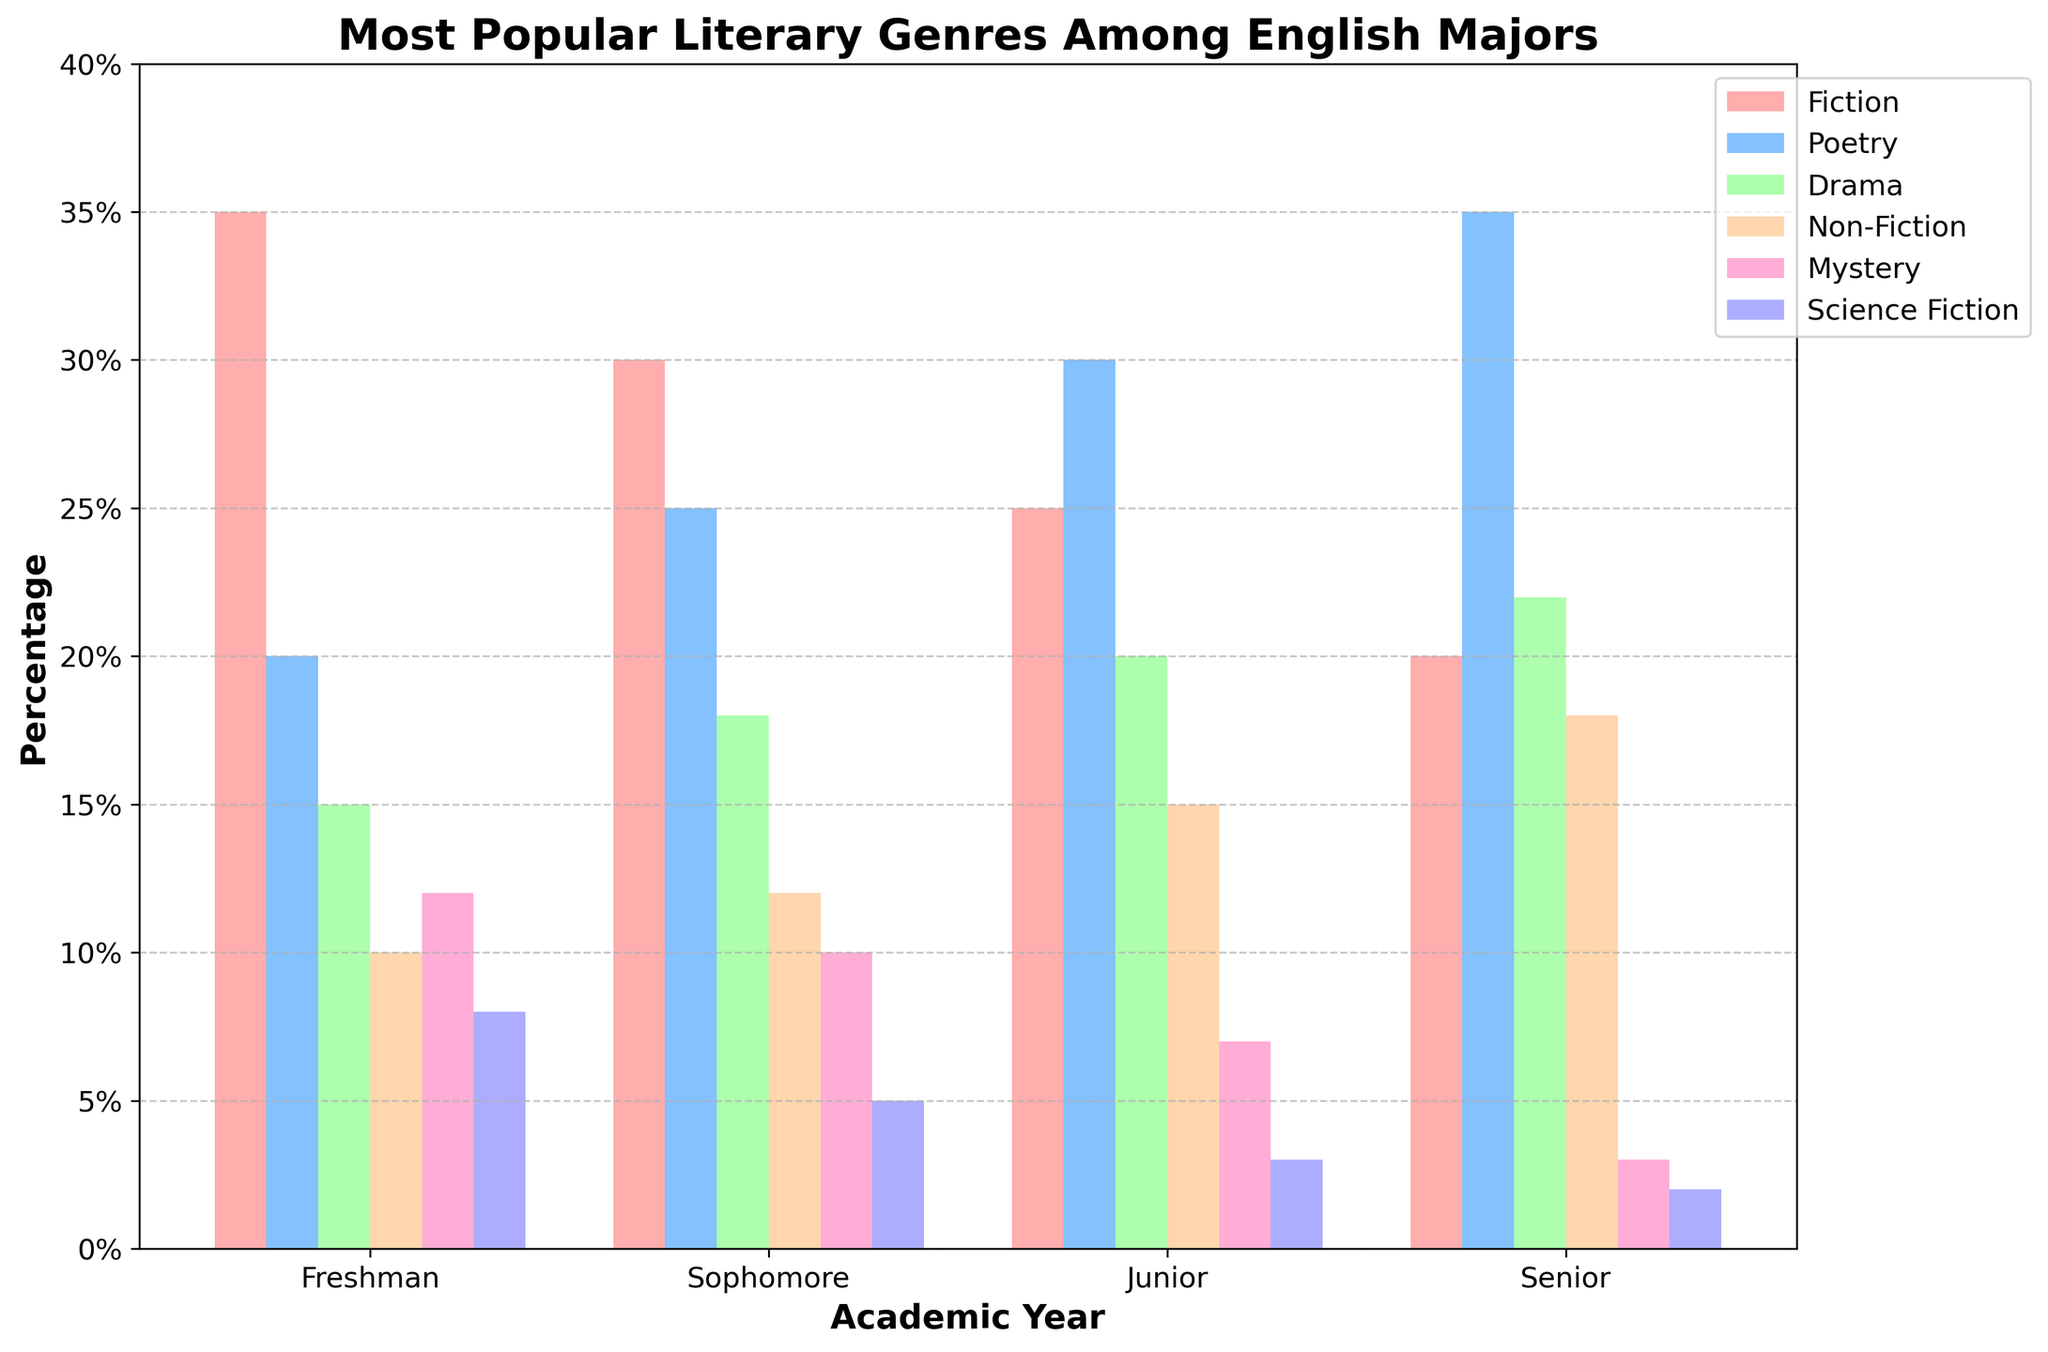How many more students prefer Fiction than Science Fiction in the Freshman year? To find the difference, subtract the number of students who prefer Science Fiction from those who prefer Fiction in the Freshman year: 35 - 8 = 27
Answer: 27 In which academic year is Poetry the most preferred genre? Review the height of the bars representing Poetry across the years; the highest is in the Senior year with 35 students.
Answer: Senior Which genre sees the most consistent increase in preference from Freshman to Senior years? Compare the change in height of each genre’s bar from Freshman to Senior years. Poetry shows a regular increase from 20 in Freshman to 35 in Senior.
Answer: Poetry What is the average percentage of students who prefer Drama across all academic years? Sum the Drama percentages across all years and divide by the number of years: (15 + 18 + 20 + 22) / 4 = 75 / 4
Answer: 18.75 Which genre do Sophomores and Juniors prefer the most? Identify the highest bars among Sophomores and Juniors. For both, Poetry is the most preferred with 25 and 30 respectively.
Answer: Poetry For which genre does the preference decline the most from Freshman to Senior year? Calculate the difference for each genre from Freshman to Senior. Fiction declines from 35 to 20, which is a drop of 15, the largest decline.
Answer: Fiction Does Mystery ever surpass Non-Fiction in popularity in any academic year? Compare the heights of Mystery and Non-Fiction bars for each year. Mystery is never higher than Non-Fiction.
Answer: No Which academic year shows the least interest in Science Fiction? Compare the bar heights for Science Fiction across all years; the lowest is in the Senior year with 2 students.
Answer: Senior What is the overall trend for Non-Fiction preference from Freshman to Senior? Observe the bars representing Non-Fiction; they consistently increase from Freshman to Senior years (10, 12, 15, 18).
Answer: Increasing What percentage of Freshmen prefer Fiction and Drama combined? Sum the percentages for Fiction and Drama in the Freshman year: 35 + 15 = 50%
Answer: 50% 